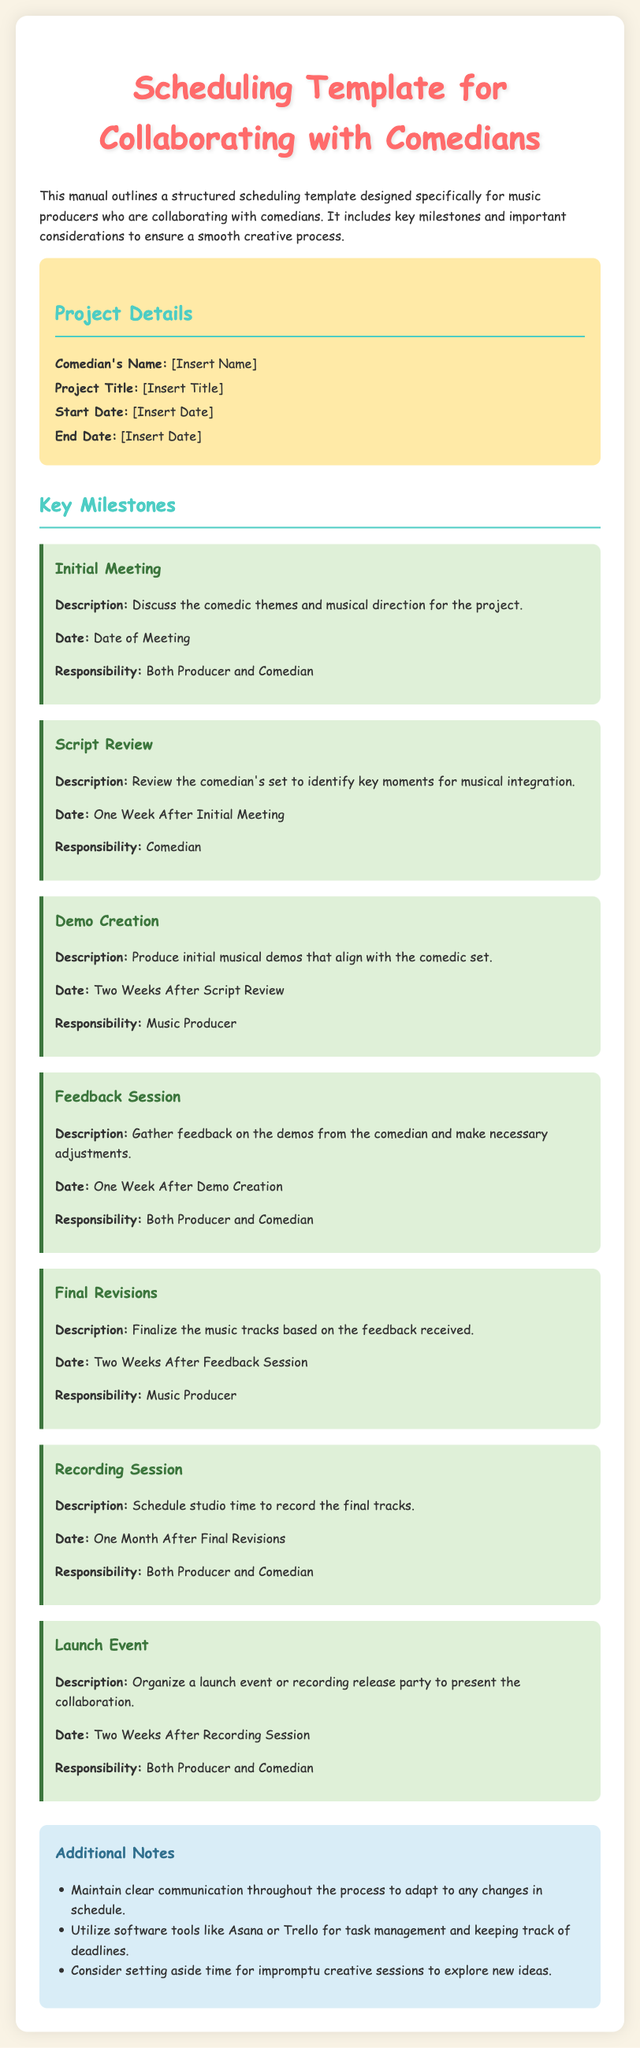What is the title of the project? The project's title is found under "Project Title" in the document where it asks for the comedian's title.
Answer: [Insert Title] What is the start date? The start date is listed in the project details, indicated by the section labeled "Start Date."
Answer: [Insert Date] Who is responsible for the script review? The responsibility for the script review is outlined under the Key Milestones section, stating who takes charge of that particular milestone.
Answer: Comedian When is the demo creation scheduled? The timing for demo creation is specified in the milestone description that follows the "Script Review" milestone, indicating the duration after that event.
Answer: Two Weeks After Script Review What is the purpose of the launch event? The launch event's purpose can be found in the description under the "Launch Event" milestone, where it details what the event is meant to achieve.
Answer: Present the collaboration What should be maintained throughout the process? This information is found in the "Additional Notes" section regarding the importance of communication, highlighting a significant factor during the project.
Answer: Clear communication How long after the final revisions is the recording session? The document specifies the scheduling for the recording session in relation to the final revisions milestone, detailing the time gap between the two.
Answer: One Month After Final Revisions What type of tools are suggested for task management? The "Additional Notes" section mentions specific software tools that can be used for managing tasks and keeping track of deadlines.
Answer: Asana or Trello What is the color of the header background? This information is inferred from the document's style section, which outlines the design elements used in the header.
Answer: #ffeaa7 What is the first milestone mentioned in the document? The first milestone is at the beginning of the Key Milestones section, where it describes the initial meeting task.
Answer: Initial Meeting 